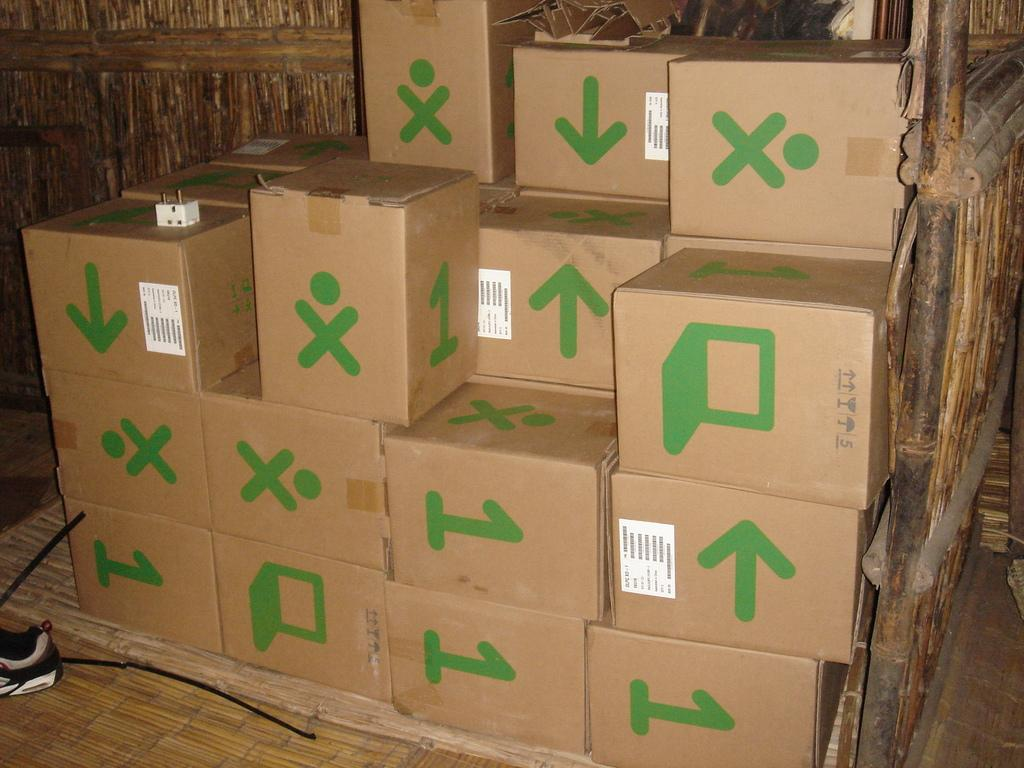<image>
Relay a brief, clear account of the picture shown. Cardboard boxes are piled up, some having the number 1 on them and others featuring the letter X. 